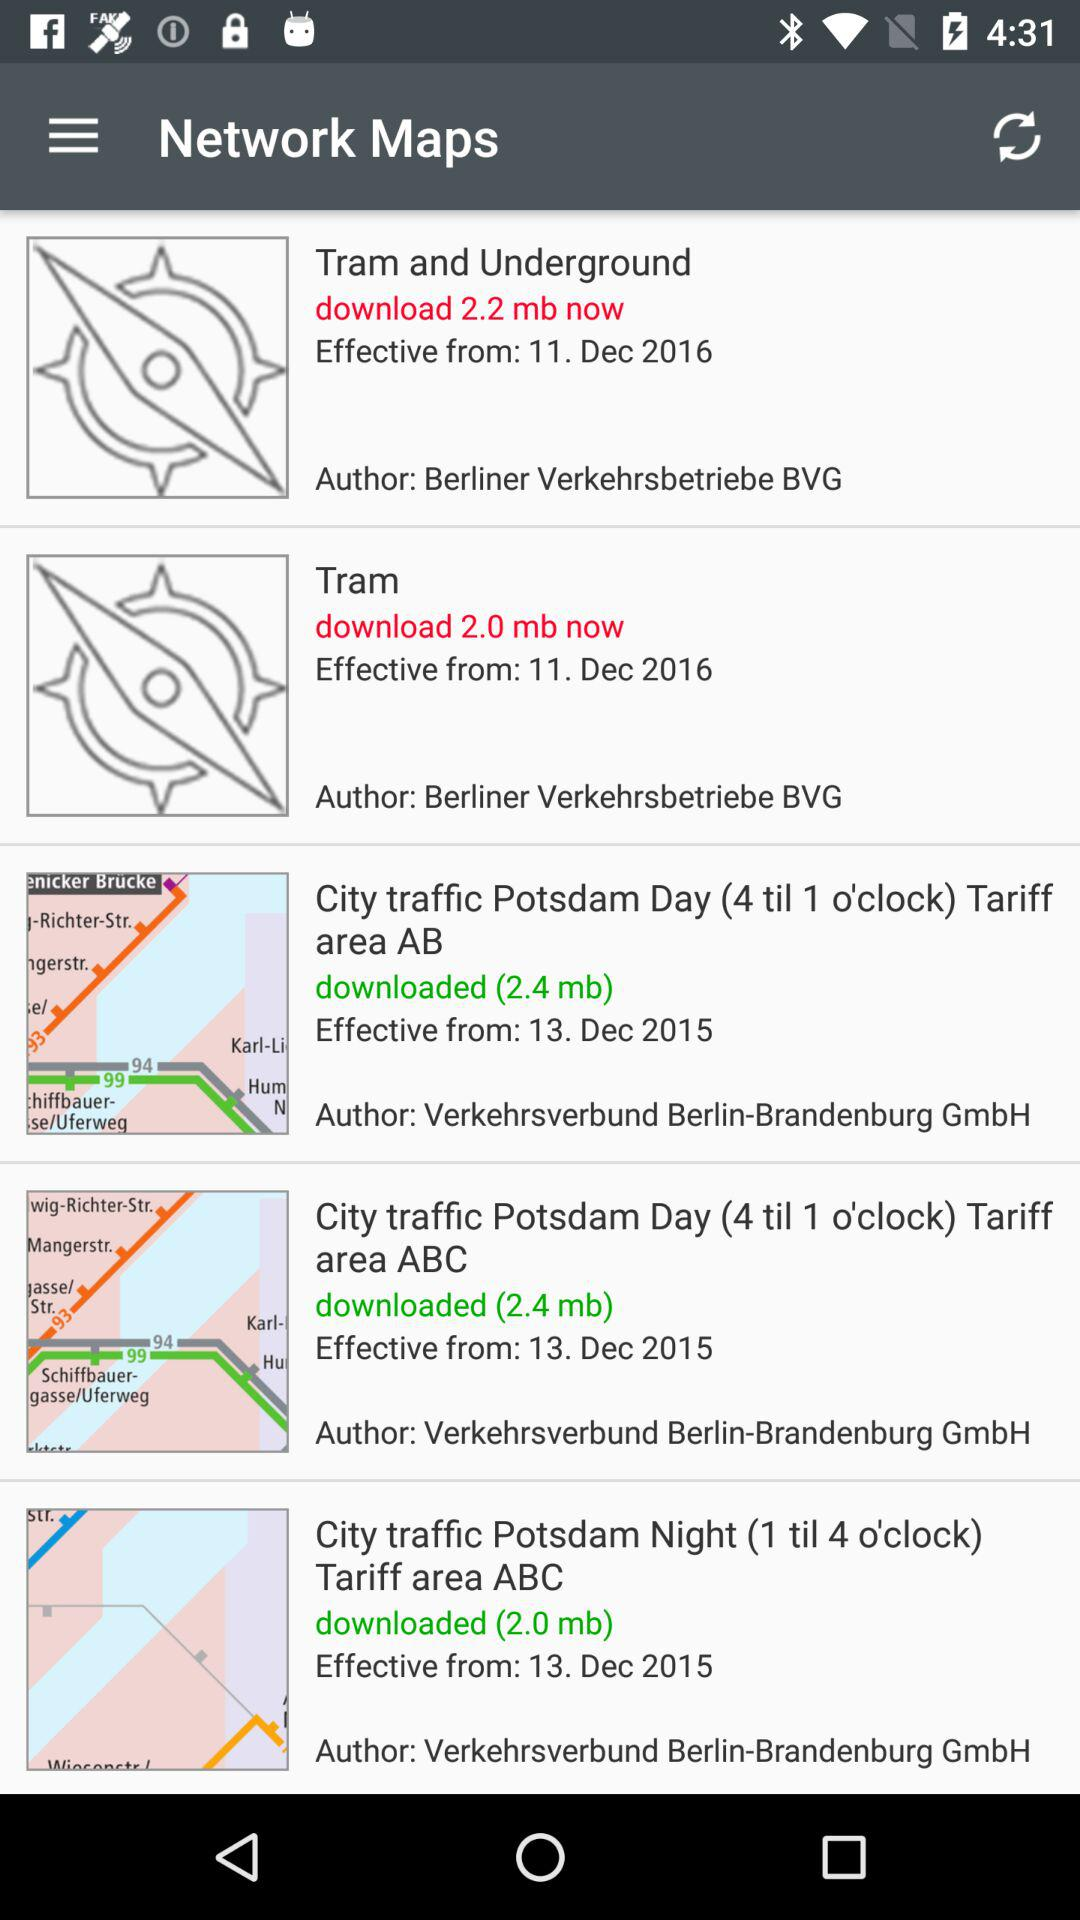Who is the author of "Tram and Underground"? The author is Berliner Verkehrsbetriebe BVG. 